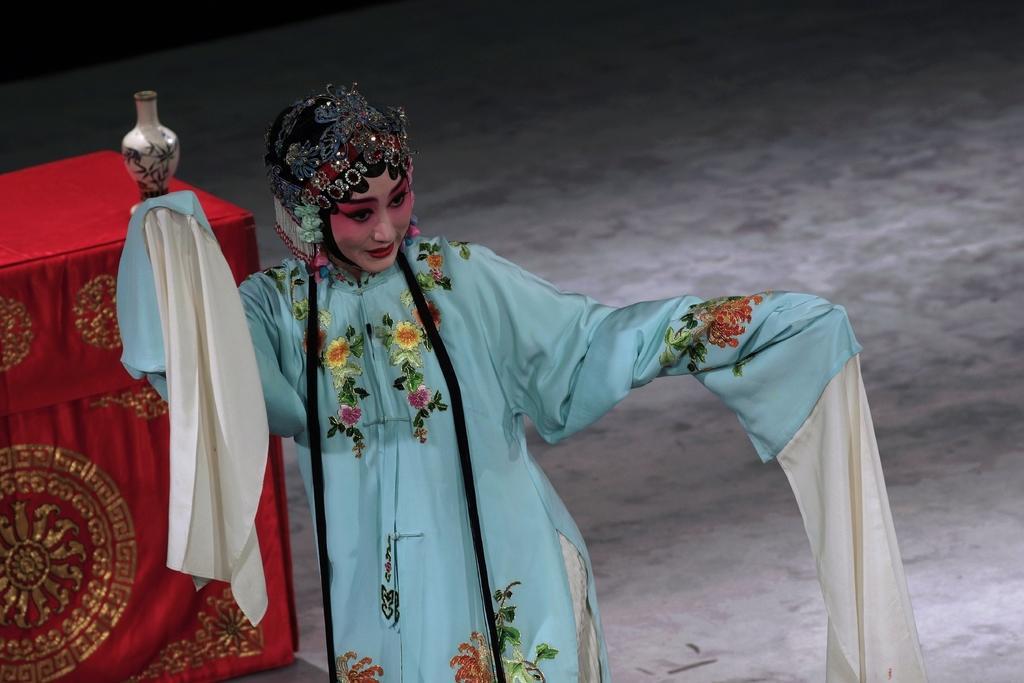Could you give a brief overview of what you see in this image? In this image there is a woman standing on the ground. She is wearing a costume. Behind her there is a table. There is a cloth spread on the table. There is a jar on the table. 